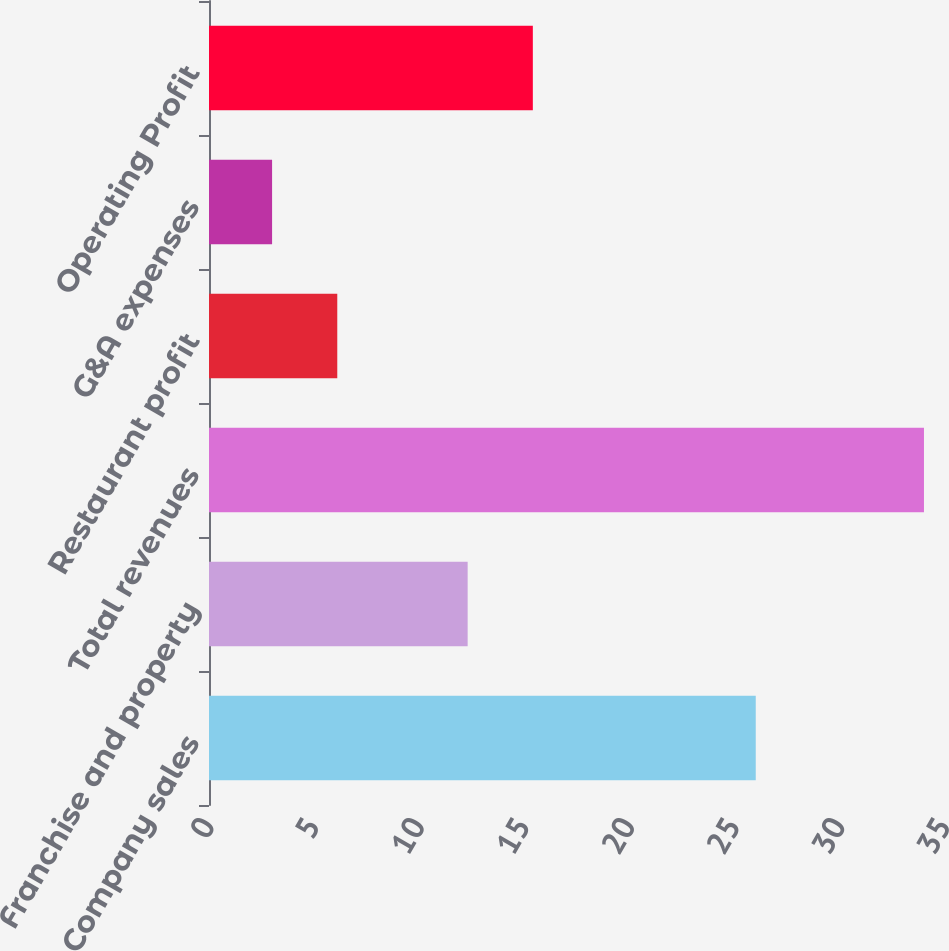Convert chart. <chart><loc_0><loc_0><loc_500><loc_500><bar_chart><fcel>Company sales<fcel>Franchise and property<fcel>Total revenues<fcel>Restaurant profit<fcel>G&A expenses<fcel>Operating Profit<nl><fcel>26<fcel>12.3<fcel>34<fcel>6.1<fcel>3<fcel>15.4<nl></chart> 